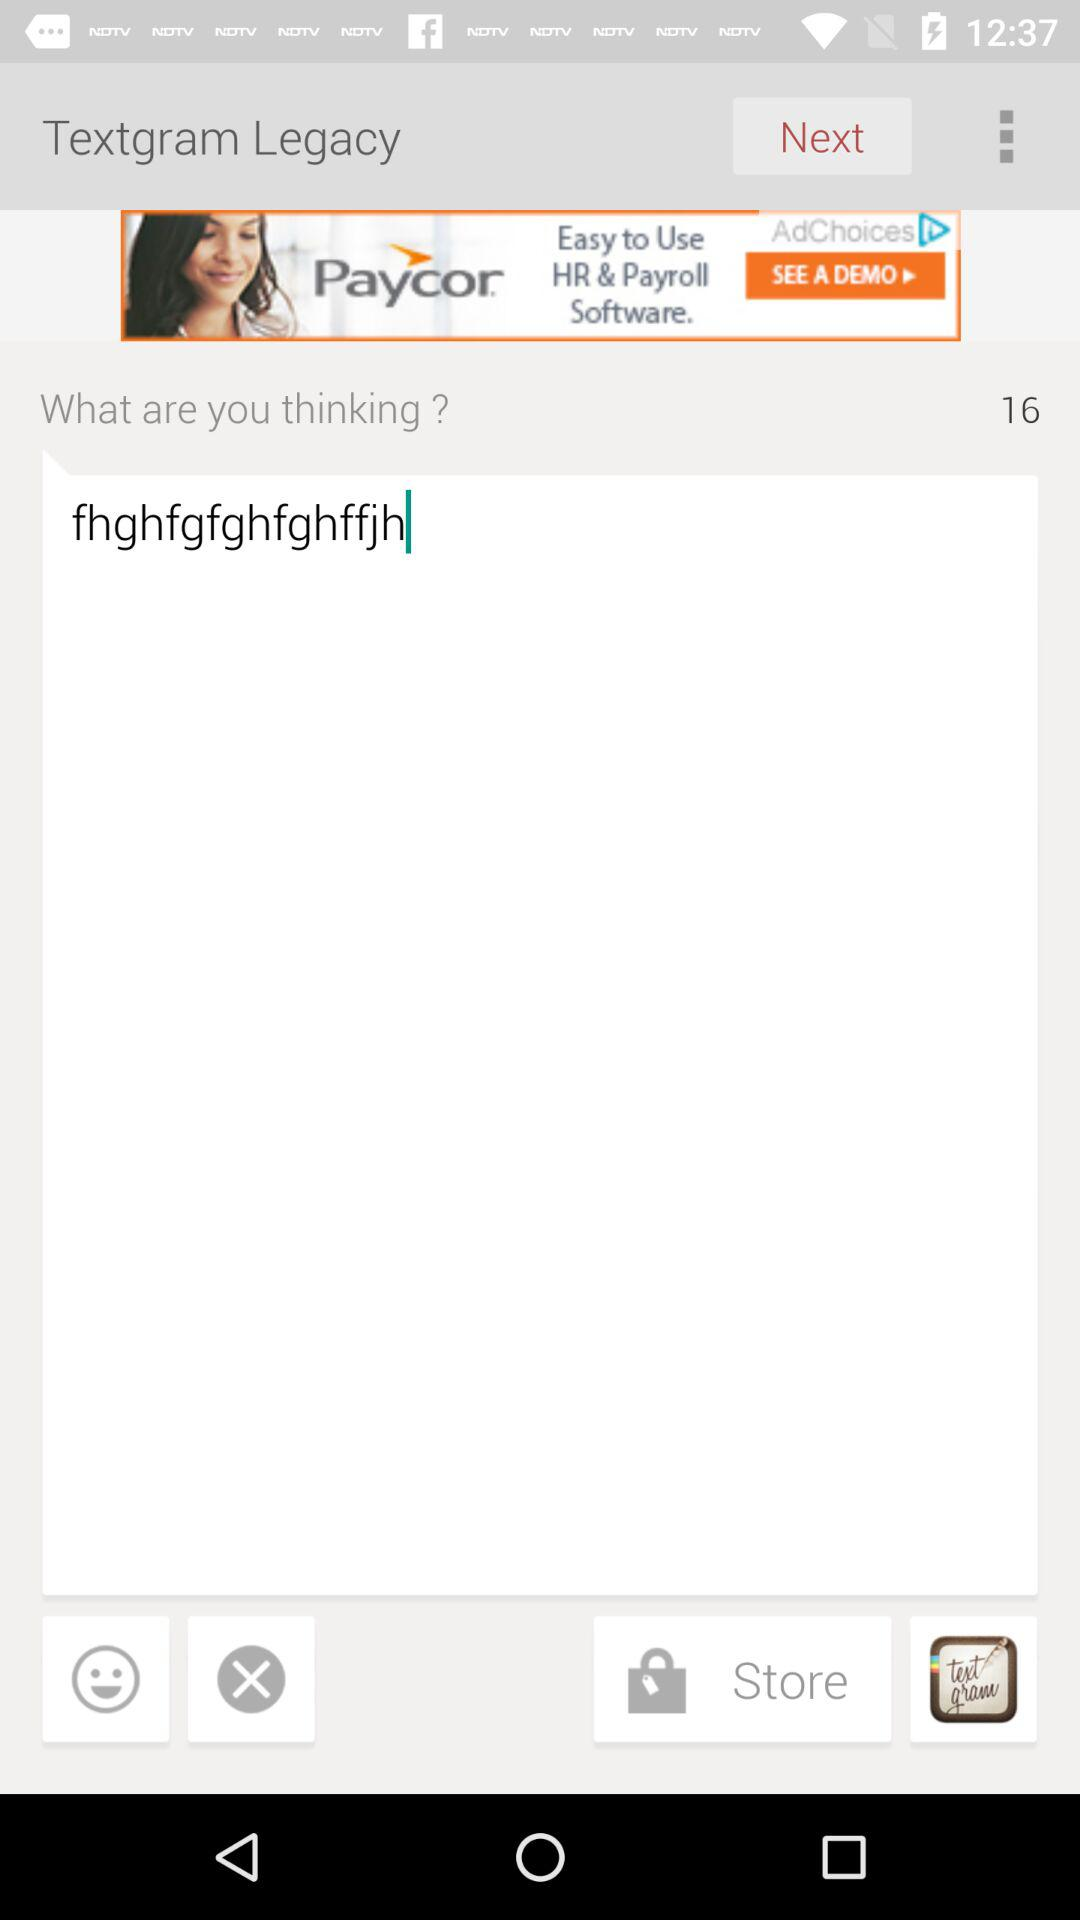What is the name of the application? The name of the application is "Textgram Legacy". 